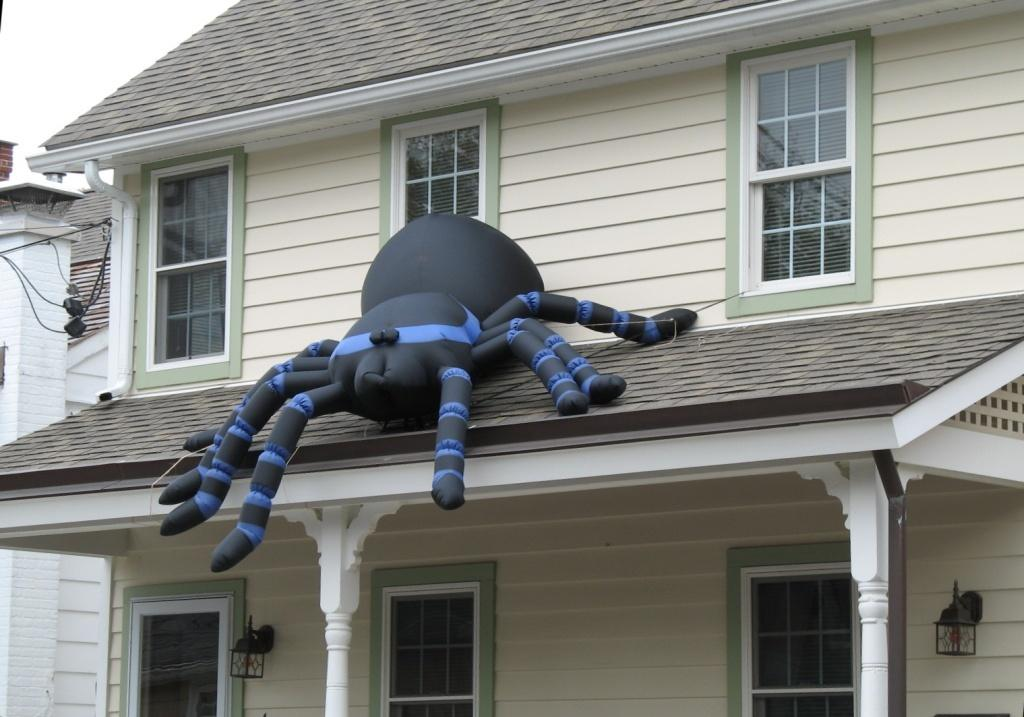What is the main object in the middle of the image? There is an inflatable object in the middle of the image. What can be seen in the background of the image? There is a building in the background of the image. What part of the sky is visible in the image? The sky is visible in the top left corner of the image. What type of shop can be seen in the image? There is no shop present in the image; it features an inflatable object and a building in the background. 